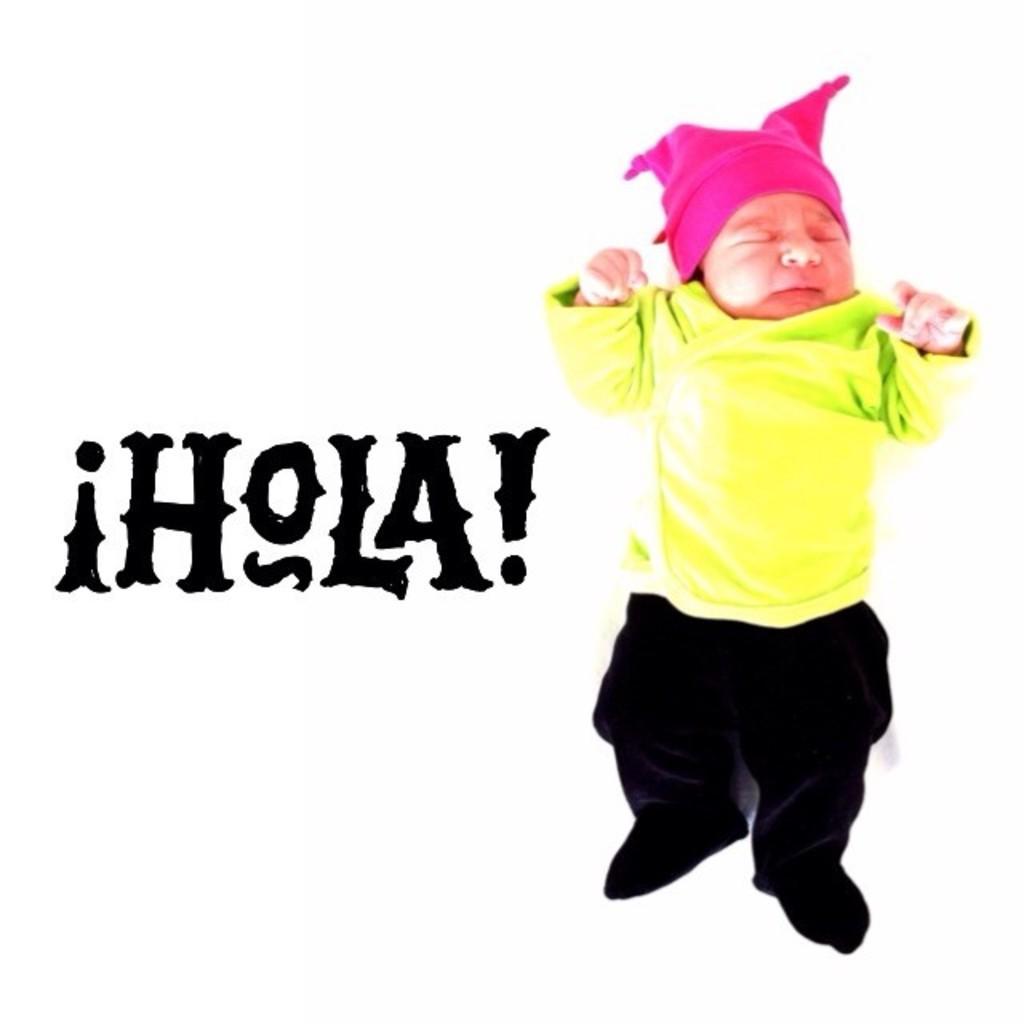In one or two sentences, can you explain what this image depicts? On the right side, we see a baby in green T-shirt and black pant is sleeping. He is wearing a pink cap. Beside him, we see some text written in black color. In the background, it is white in color. 